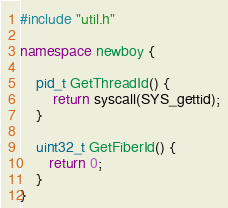<code> <loc_0><loc_0><loc_500><loc_500><_C++_>#include "util.h"

namespace newboy {
    
    pid_t GetThreadId() {
        return syscall(SYS_gettid);
    }

    uint32_t GetFiberId() {
       return 0;
    }
}</code> 